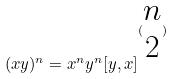<formula> <loc_0><loc_0><loc_500><loc_500>( x y ) ^ { n } = x ^ { n } y ^ { n } [ y , x ] ^ { ( \begin{matrix} n \\ 2 \end{matrix} ) }</formula> 